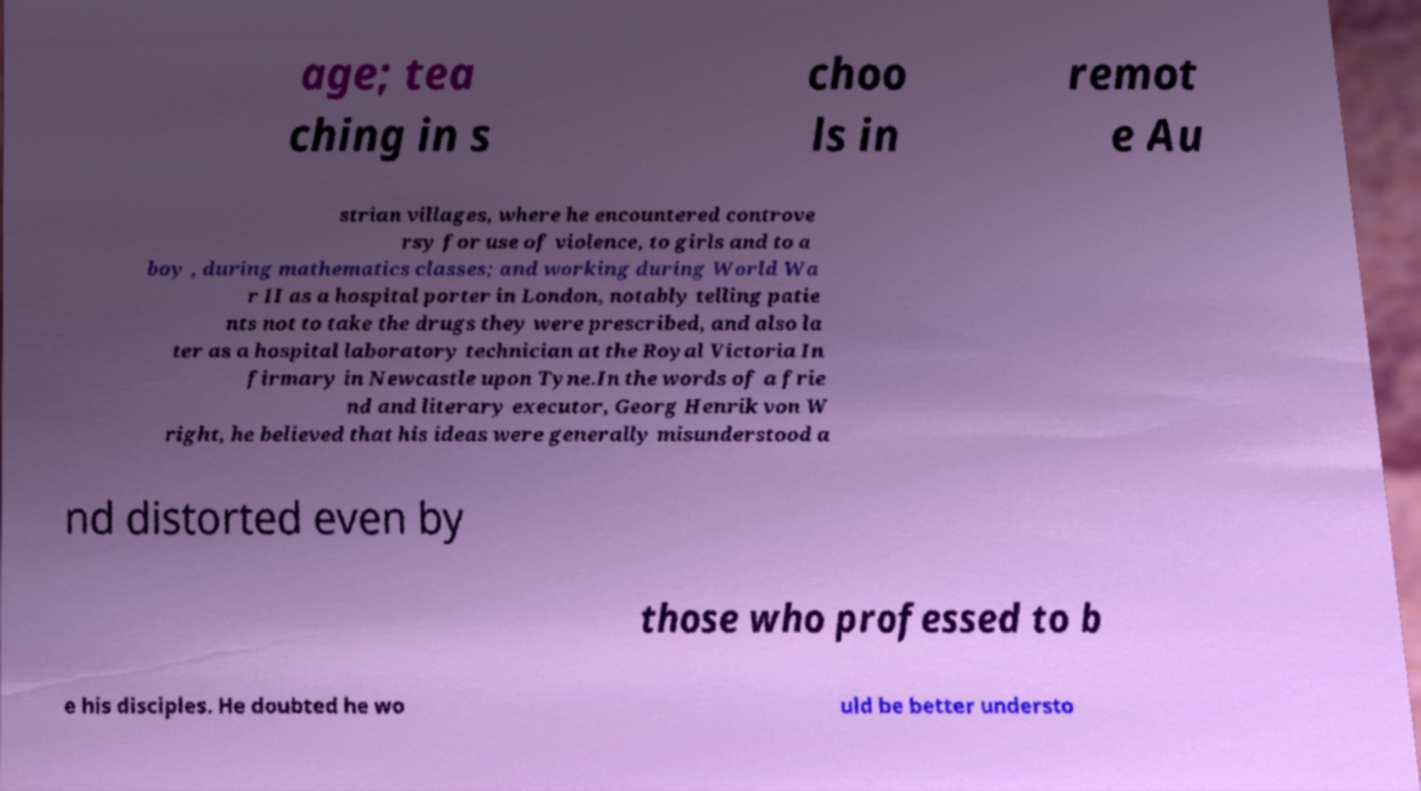I need the written content from this picture converted into text. Can you do that? age; tea ching in s choo ls in remot e Au strian villages, where he encountered controve rsy for use of violence, to girls and to a boy , during mathematics classes; and working during World Wa r II as a hospital porter in London, notably telling patie nts not to take the drugs they were prescribed, and also la ter as a hospital laboratory technician at the Royal Victoria In firmary in Newcastle upon Tyne.In the words of a frie nd and literary executor, Georg Henrik von W right, he believed that his ideas were generally misunderstood a nd distorted even by those who professed to b e his disciples. He doubted he wo uld be better understo 